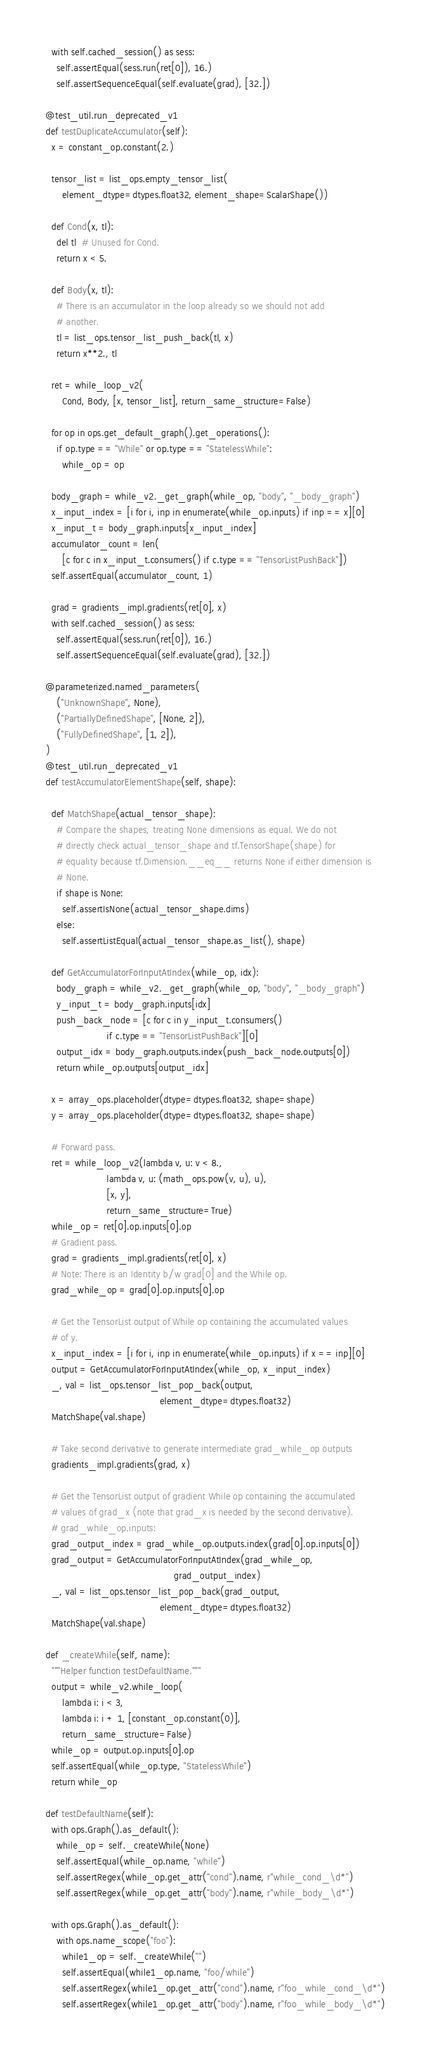<code> <loc_0><loc_0><loc_500><loc_500><_Python_>    with self.cached_session() as sess:
      self.assertEqual(sess.run(ret[0]), 16.)
      self.assertSequenceEqual(self.evaluate(grad), [32.])

  @test_util.run_deprecated_v1
  def testDuplicateAccumulator(self):
    x = constant_op.constant(2.)

    tensor_list = list_ops.empty_tensor_list(
        element_dtype=dtypes.float32, element_shape=ScalarShape())

    def Cond(x, tl):
      del tl  # Unused for Cond.
      return x < 5.

    def Body(x, tl):
      # There is an accumulator in the loop already so we should not add
      # another.
      tl = list_ops.tensor_list_push_back(tl, x)
      return x**2., tl

    ret = while_loop_v2(
        Cond, Body, [x, tensor_list], return_same_structure=False)

    for op in ops.get_default_graph().get_operations():
      if op.type == "While" or op.type == "StatelessWhile":
        while_op = op

    body_graph = while_v2._get_graph(while_op, "body", "_body_graph")
    x_input_index = [i for i, inp in enumerate(while_op.inputs) if inp == x][0]
    x_input_t = body_graph.inputs[x_input_index]
    accumulator_count = len(
        [c for c in x_input_t.consumers() if c.type == "TensorListPushBack"])
    self.assertEqual(accumulator_count, 1)

    grad = gradients_impl.gradients(ret[0], x)
    with self.cached_session() as sess:
      self.assertEqual(sess.run(ret[0]), 16.)
      self.assertSequenceEqual(self.evaluate(grad), [32.])

  @parameterized.named_parameters(
      ("UnknownShape", None),
      ("PartiallyDefinedShape", [None, 2]),
      ("FullyDefinedShape", [1, 2]),
  )
  @test_util.run_deprecated_v1
  def testAccumulatorElementShape(self, shape):

    def MatchShape(actual_tensor_shape):
      # Compare the shapes, treating None dimensions as equal. We do not
      # directly check actual_tensor_shape and tf.TensorShape(shape) for
      # equality because tf.Dimension.__eq__ returns None if either dimension is
      # None.
      if shape is None:
        self.assertIsNone(actual_tensor_shape.dims)
      else:
        self.assertListEqual(actual_tensor_shape.as_list(), shape)

    def GetAccumulatorForInputAtIndex(while_op, idx):
      body_graph = while_v2._get_graph(while_op, "body", "_body_graph")
      y_input_t = body_graph.inputs[idx]
      push_back_node = [c for c in y_input_t.consumers()
                        if c.type == "TensorListPushBack"][0]
      output_idx = body_graph.outputs.index(push_back_node.outputs[0])
      return while_op.outputs[output_idx]

    x = array_ops.placeholder(dtype=dtypes.float32, shape=shape)
    y = array_ops.placeholder(dtype=dtypes.float32, shape=shape)

    # Forward pass.
    ret = while_loop_v2(lambda v, u: v < 8.,
                        lambda v, u: (math_ops.pow(v, u), u),
                        [x, y],
                        return_same_structure=True)
    while_op = ret[0].op.inputs[0].op
    # Gradient pass.
    grad = gradients_impl.gradients(ret[0], x)
    # Note: There is an Identity b/w grad[0] and the While op.
    grad_while_op = grad[0].op.inputs[0].op

    # Get the TensorList output of While op containing the accumulated values
    # of y.
    x_input_index = [i for i, inp in enumerate(while_op.inputs) if x == inp][0]
    output = GetAccumulatorForInputAtIndex(while_op, x_input_index)
    _, val = list_ops.tensor_list_pop_back(output,
                                           element_dtype=dtypes.float32)
    MatchShape(val.shape)

    # Take second derivative to generate intermediate grad_while_op outputs
    gradients_impl.gradients(grad, x)

    # Get the TensorList output of gradient While op containing the accumulated
    # values of grad_x (note that grad_x is needed by the second derivative).
    # grad_while_op.inputs:
    grad_output_index = grad_while_op.outputs.index(grad[0].op.inputs[0])
    grad_output = GetAccumulatorForInputAtIndex(grad_while_op,
                                                grad_output_index)
    _, val = list_ops.tensor_list_pop_back(grad_output,
                                           element_dtype=dtypes.float32)
    MatchShape(val.shape)

  def _createWhile(self, name):
    """Helper function testDefaultName."""
    output = while_v2.while_loop(
        lambda i: i < 3,
        lambda i: i + 1, [constant_op.constant(0)],
        return_same_structure=False)
    while_op = output.op.inputs[0].op
    self.assertEqual(while_op.type, "StatelessWhile")
    return while_op

  def testDefaultName(self):
    with ops.Graph().as_default():
      while_op = self._createWhile(None)
      self.assertEqual(while_op.name, "while")
      self.assertRegex(while_op.get_attr("cond").name, r"while_cond_\d*")
      self.assertRegex(while_op.get_attr("body").name, r"while_body_\d*")

    with ops.Graph().as_default():
      with ops.name_scope("foo"):
        while1_op = self._createWhile("")
        self.assertEqual(while1_op.name, "foo/while")
        self.assertRegex(while1_op.get_attr("cond").name, r"foo_while_cond_\d*")
        self.assertRegex(while1_op.get_attr("body").name, r"foo_while_body_\d*")
</code> 